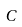Convert formula to latex. <formula><loc_0><loc_0><loc_500><loc_500>C</formula> 